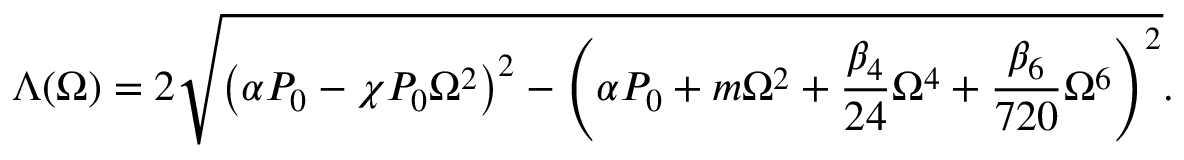Convert formula to latex. <formula><loc_0><loc_0><loc_500><loc_500>\Lambda ( \Omega ) = 2 \sqrt { \left ( \alpha P _ { 0 } - \chi P _ { 0 } \Omega ^ { 2 } \right ) ^ { 2 } - \left ( \alpha P _ { 0 } + m \Omega ^ { 2 } + \frac { \beta _ { 4 } } { 2 4 } \Omega ^ { 4 } + \frac { \beta _ { 6 } } { 7 2 0 } \Omega ^ { 6 } \right ) ^ { 2 } } .</formula> 